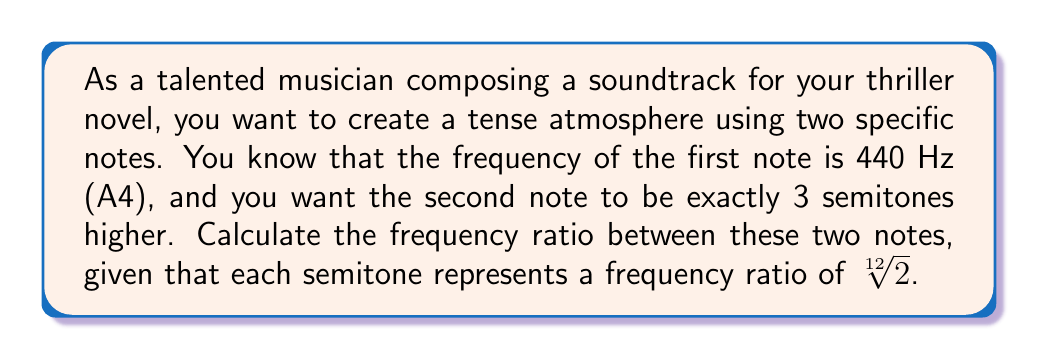Help me with this question. To solve this problem, we need to follow these steps:

1) First, recall that the frequency ratio for a single semitone is $\sqrt[12]{2}$.

2) Since we're looking for a note that's 3 semitones higher, we need to multiply this ratio by itself 3 times:

   $(\sqrt[12]{2})^3$

3) This can be simplified using the properties of exponents:

   $(\sqrt[12]{2})^3 = \sqrt[12]{2^3} = \sqrt[12]{8}$

4) To calculate this precisely, we can use the following:

   $\sqrt[12]{8} = 8^{\frac{1}{12}} = 2^{\frac{3}{12}} = 2^{\frac{1}{4}} = \sqrt{\sqrt{2}}$

5) Using a calculator, we can find that:

   $\sqrt{\sqrt{2}} \approx 1.189207115$

This means that the frequency of the higher note is approximately 1.189207115 times the frequency of the lower note.
Answer: The frequency ratio between the two notes is $\sqrt{\sqrt{2}}$, or approximately 1.189207115. 